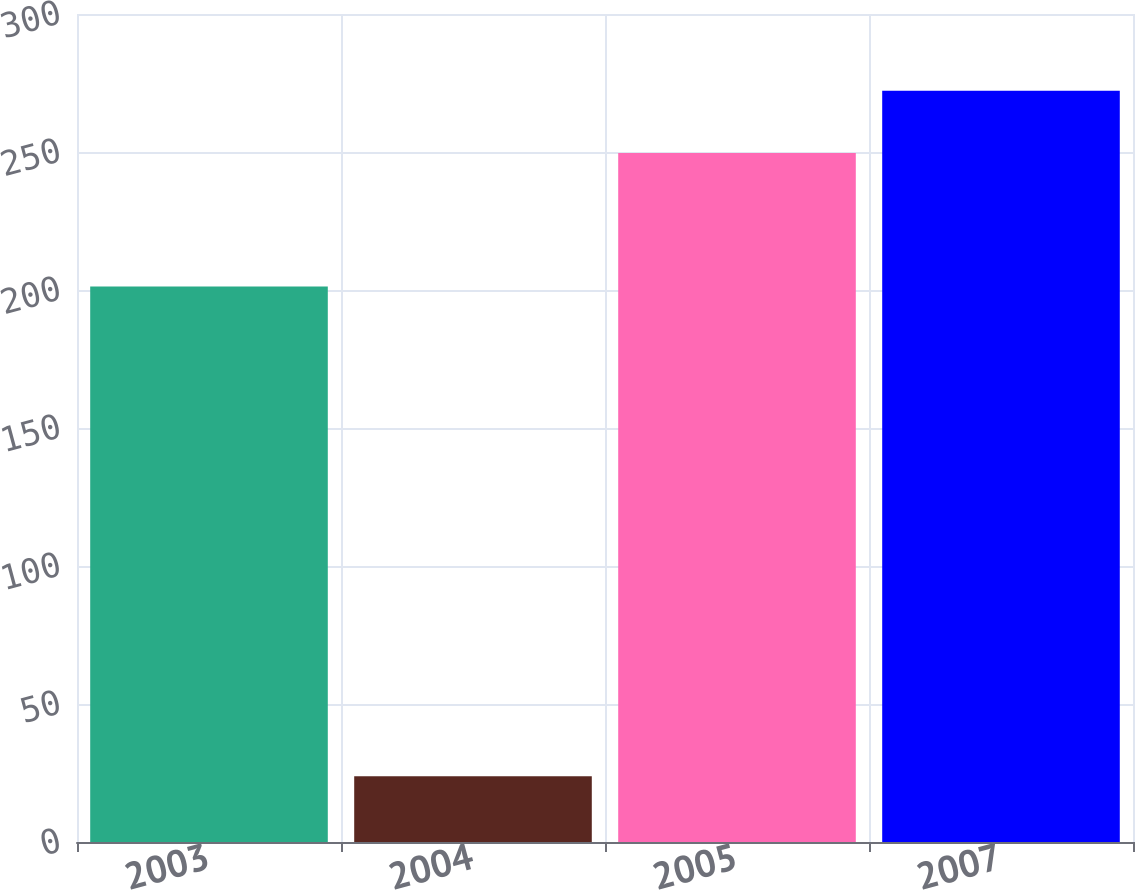Convert chart. <chart><loc_0><loc_0><loc_500><loc_500><bar_chart><fcel>2003<fcel>2004<fcel>2005<fcel>2007<nl><fcel>201.3<fcel>23.8<fcel>249.6<fcel>272.2<nl></chart> 